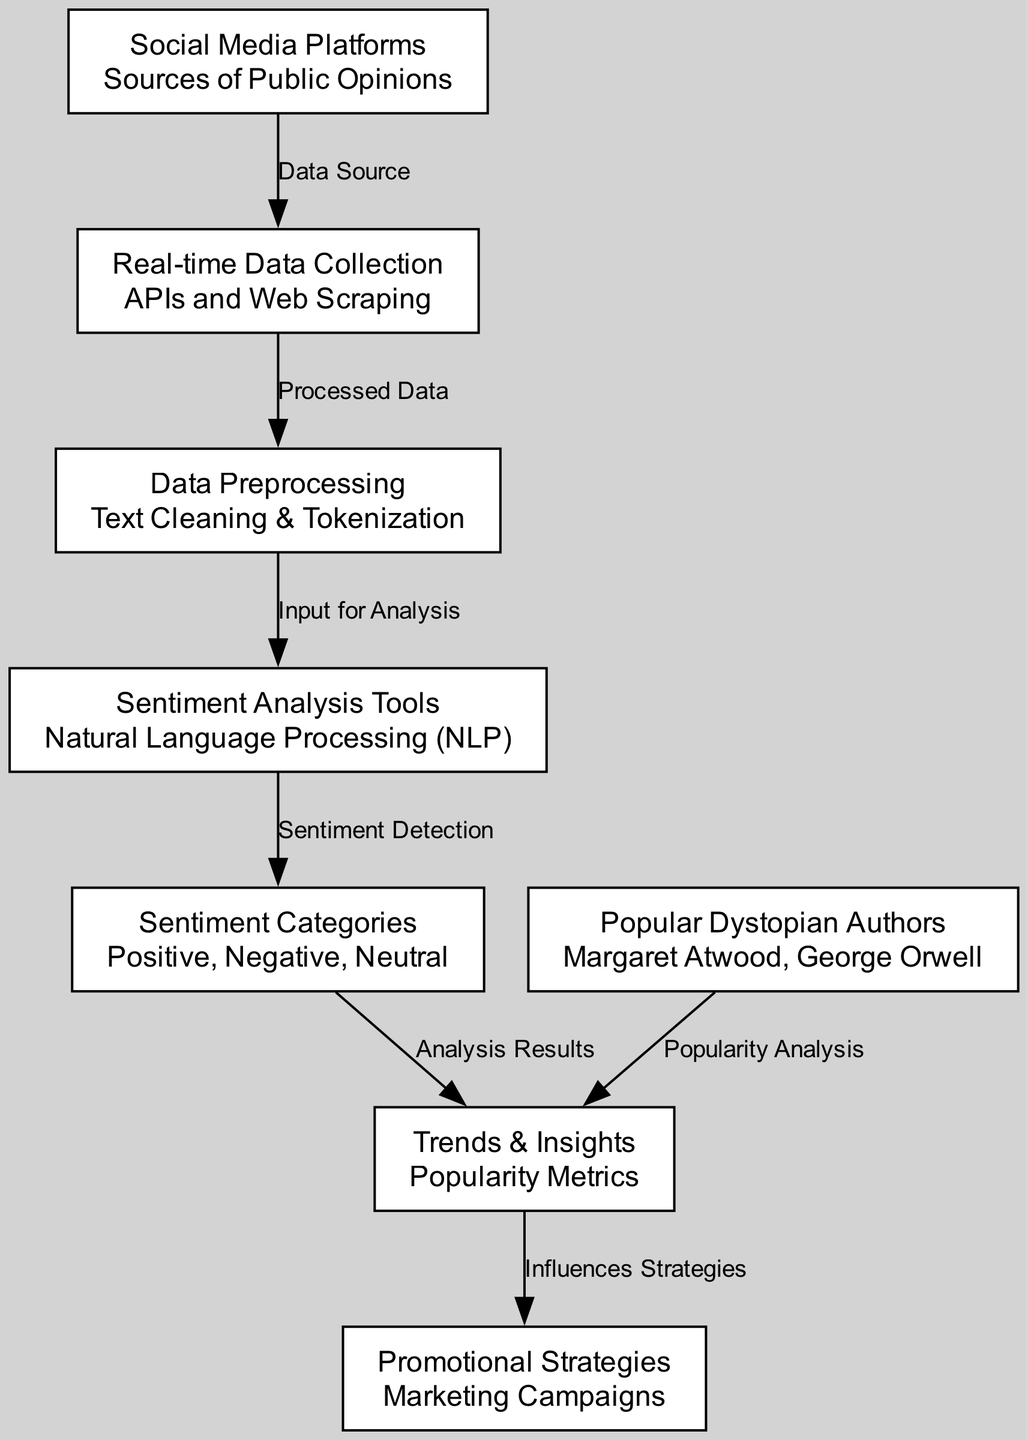What are the sources of public opinions according to the diagram? In the diagram, the node labeled "Social Media Platforms" specifically defines the sources of public opinions. This is indicated by the label and description provided for that node.
Answer: Social Media Platforms Which tools are mentioned for sentiment analysis in the diagram? The node labeled "Sentiment Analysis Tools" is presented, specifically stating "Natural Language Processing (NLP" as the tool used for sentiment analysis.
Answer: Natural Language Processing (NLP) How many nodes are there in the diagram? The diagram includes a total of eight distinct nodes, each representing different components related to social media influence and dystopian fiction popularity.
Answer: 8 What type of analysis is derived from the sentiment categories? The diagram indicates that "Analysis Results" stem from the "Sentiment Categories," indicating that the output of the sentiment analysis is categorized into positive, negative, or neutral sentiments.
Answer: Analysis Results Which node does "Data Preprocessing" directly connect to? The diagram depicts a relationship where "Data Preprocessing" connects directly to "Sentiment Analysis Tools," indicating that preprocessed data is used as input for analysis.
Answer: Sentiment Analysis Tools How do popular dystopian authors influence popularity metrics? The diagram shows that "Popular Dystopian Authors" connects directly to "Trends & Insights," indicating that their works are analyzed for popularity metrics, resulting in relevant insights.
Answer: Trends & Insights What is the relationship between sentiment analysis and popularity metrics? The edges in the diagram illustrate that "Sentiment Analysis Tools" lead to "Sentiment Categories" which then connect to "Trends & Insights," demonstrating that the results of sentiment analysis directly impact the understanding of popularity metrics.
Answer: Trends & Insights What acts as a data source in the diagram? The node labeled "Social Media Platforms" is identified as the primary source of data, indicating that public opinions collected from these platforms are foundational to the analysis.
Answer: Social Media Platforms 